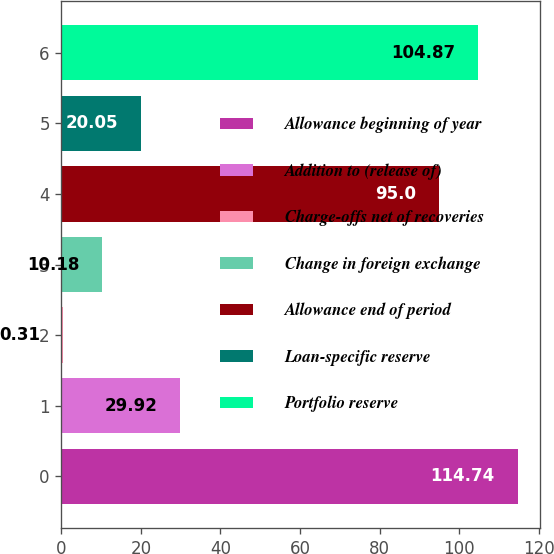Convert chart to OTSL. <chart><loc_0><loc_0><loc_500><loc_500><bar_chart><fcel>Allowance beginning of year<fcel>Addition to (release of)<fcel>Charge-offs net of recoveries<fcel>Change in foreign exchange<fcel>Allowance end of period<fcel>Loan-specific reserve<fcel>Portfolio reserve<nl><fcel>114.74<fcel>29.92<fcel>0.31<fcel>10.18<fcel>95<fcel>20.05<fcel>104.87<nl></chart> 